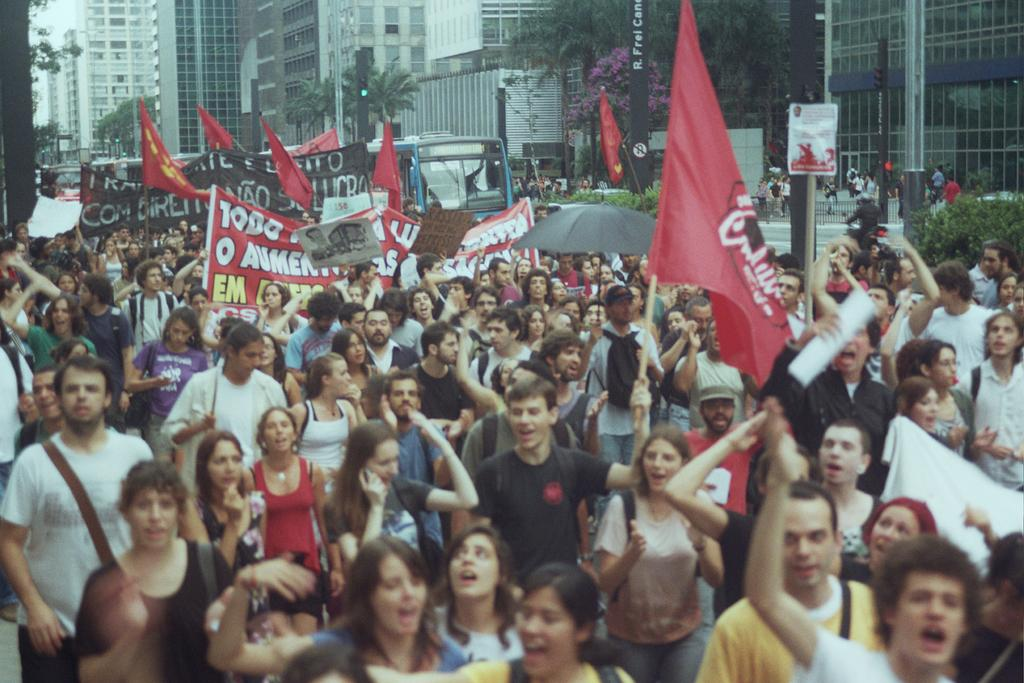How many people are present in the image? There are many people in the image. What are the people wearing? The people are wearing clothes. What can be seen hanging in the image? There are banners and a flag in the image. What structure is present in the image? There is a pole in the image. What type of pathway is visible in the image? There is a road in the image. What type of vegetation is present in the image? There is a plant and trees in the image. What type of man-made structures are present in the image? There are buildings in the image. What part of the natural environment is visible in the image? The sky is visible in the image. What type of wound can be seen on the butter in the image? There is no butter or wound present in the image. 